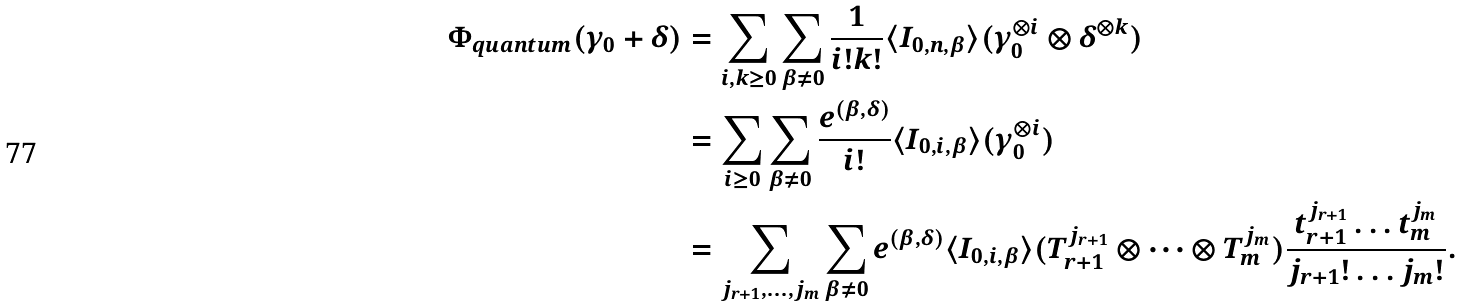<formula> <loc_0><loc_0><loc_500><loc_500>\Phi _ { q u a n t u m } ( \gamma _ { 0 } + \delta ) & = \sum _ { i , k \geq 0 } \sum _ { \beta \neq 0 } \frac { 1 } { i ! k ! } \langle I _ { 0 , n , \beta } \rangle ( \gamma _ { 0 } ^ { \otimes i } \otimes \delta ^ { \otimes k } ) \\ & = \sum _ { i \geq 0 } \sum _ { \beta \neq 0 } \frac { e ^ { ( \beta , \delta ) } } { i ! } \langle I _ { 0 , i , \beta } \rangle ( \gamma _ { 0 } ^ { \otimes i } ) \\ & = \sum _ { j _ { r + 1 } , \dots , j _ { m } } \sum _ { \beta \neq 0 } e ^ { ( \beta , \delta ) } \langle I _ { 0 , i , \beta } \rangle ( T _ { r + 1 } ^ { j _ { r + 1 } } \otimes \dots \otimes T _ { m } ^ { j _ { m } } ) \frac { t _ { r + 1 } ^ { j _ { r + 1 } } \dots t _ { m } ^ { j _ { m } } } { j _ { r + 1 } ! \dots j _ { m } ! } .</formula> 